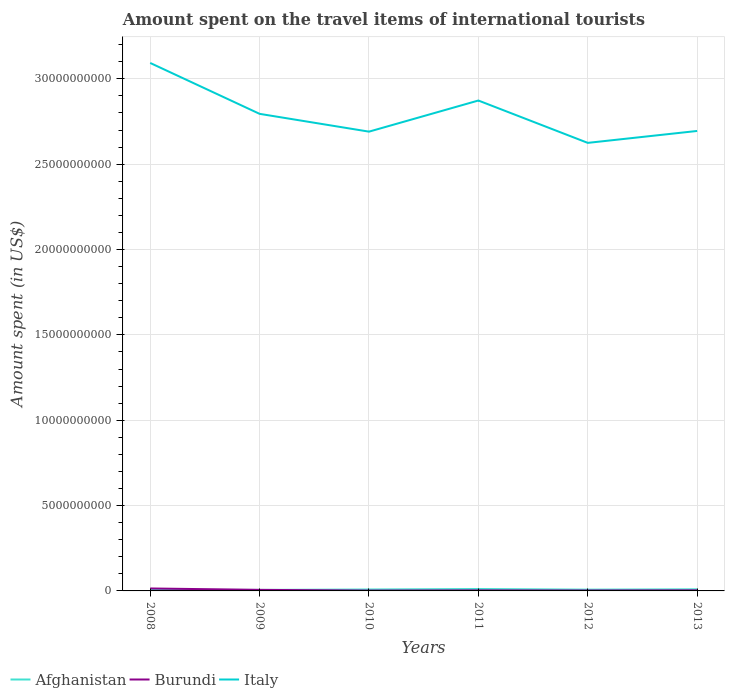How many different coloured lines are there?
Make the answer very short. 3. Is the number of lines equal to the number of legend labels?
Provide a succinct answer. Yes. Across all years, what is the maximum amount spent on the travel items of international tourists in Burundi?
Offer a very short reply. 2.00e+07. What is the total amount spent on the travel items of international tourists in Burundi in the graph?
Offer a terse response. 6.00e+06. What is the difference between the highest and the second highest amount spent on the travel items of international tourists in Afghanistan?
Provide a short and direct response. 5.80e+07. What is the difference between the highest and the lowest amount spent on the travel items of international tourists in Italy?
Keep it short and to the point. 2. Is the amount spent on the travel items of international tourists in Burundi strictly greater than the amount spent on the travel items of international tourists in Afghanistan over the years?
Your answer should be compact. No. How many lines are there?
Make the answer very short. 3. How many years are there in the graph?
Provide a succinct answer. 6. What is the difference between two consecutive major ticks on the Y-axis?
Your answer should be very brief. 5.00e+09. Are the values on the major ticks of Y-axis written in scientific E-notation?
Make the answer very short. No. Does the graph contain any zero values?
Offer a very short reply. No. Does the graph contain grids?
Give a very brief answer. Yes. Where does the legend appear in the graph?
Keep it short and to the point. Bottom left. How many legend labels are there?
Your answer should be compact. 3. What is the title of the graph?
Your answer should be compact. Amount spent on the travel items of international tourists. What is the label or title of the Y-axis?
Give a very brief answer. Amount spent (in US$). What is the Amount spent (in US$) in Afghanistan in 2008?
Give a very brief answer. 5.50e+07. What is the Amount spent (in US$) of Burundi in 2008?
Give a very brief answer. 1.44e+08. What is the Amount spent (in US$) of Italy in 2008?
Keep it short and to the point. 3.09e+1. What is the Amount spent (in US$) of Afghanistan in 2009?
Your answer should be compact. 5.90e+07. What is the Amount spent (in US$) in Burundi in 2009?
Provide a succinct answer. 6.20e+07. What is the Amount spent (in US$) in Italy in 2009?
Give a very brief answer. 2.80e+1. What is the Amount spent (in US$) in Afghanistan in 2010?
Your response must be concise. 8.30e+07. What is the Amount spent (in US$) of Italy in 2010?
Ensure brevity in your answer.  2.69e+1. What is the Amount spent (in US$) in Afghanistan in 2011?
Provide a succinct answer. 1.13e+08. What is the Amount spent (in US$) in Burundi in 2011?
Ensure brevity in your answer.  3.10e+07. What is the Amount spent (in US$) of Italy in 2011?
Your answer should be very brief. 2.87e+1. What is the Amount spent (in US$) in Afghanistan in 2012?
Give a very brief answer. 7.50e+07. What is the Amount spent (in US$) in Burundi in 2012?
Give a very brief answer. 2.50e+07. What is the Amount spent (in US$) in Italy in 2012?
Give a very brief answer. 2.62e+1. What is the Amount spent (in US$) in Afghanistan in 2013?
Make the answer very short. 9.40e+07. What is the Amount spent (in US$) of Burundi in 2013?
Your answer should be compact. 3.40e+07. What is the Amount spent (in US$) of Italy in 2013?
Your response must be concise. 2.69e+1. Across all years, what is the maximum Amount spent (in US$) of Afghanistan?
Make the answer very short. 1.13e+08. Across all years, what is the maximum Amount spent (in US$) of Burundi?
Make the answer very short. 1.44e+08. Across all years, what is the maximum Amount spent (in US$) of Italy?
Give a very brief answer. 3.09e+1. Across all years, what is the minimum Amount spent (in US$) of Afghanistan?
Your answer should be very brief. 5.50e+07. Across all years, what is the minimum Amount spent (in US$) of Italy?
Provide a short and direct response. 2.62e+1. What is the total Amount spent (in US$) in Afghanistan in the graph?
Your answer should be compact. 4.79e+08. What is the total Amount spent (in US$) in Burundi in the graph?
Provide a succinct answer. 3.16e+08. What is the total Amount spent (in US$) of Italy in the graph?
Provide a short and direct response. 1.68e+11. What is the difference between the Amount spent (in US$) of Burundi in 2008 and that in 2009?
Provide a succinct answer. 8.20e+07. What is the difference between the Amount spent (in US$) of Italy in 2008 and that in 2009?
Provide a short and direct response. 2.98e+09. What is the difference between the Amount spent (in US$) in Afghanistan in 2008 and that in 2010?
Give a very brief answer. -2.80e+07. What is the difference between the Amount spent (in US$) of Burundi in 2008 and that in 2010?
Your answer should be compact. 1.24e+08. What is the difference between the Amount spent (in US$) in Italy in 2008 and that in 2010?
Make the answer very short. 4.02e+09. What is the difference between the Amount spent (in US$) of Afghanistan in 2008 and that in 2011?
Make the answer very short. -5.80e+07. What is the difference between the Amount spent (in US$) of Burundi in 2008 and that in 2011?
Your response must be concise. 1.13e+08. What is the difference between the Amount spent (in US$) of Italy in 2008 and that in 2011?
Provide a succinct answer. 2.20e+09. What is the difference between the Amount spent (in US$) of Afghanistan in 2008 and that in 2012?
Provide a succinct answer. -2.00e+07. What is the difference between the Amount spent (in US$) of Burundi in 2008 and that in 2012?
Make the answer very short. 1.19e+08. What is the difference between the Amount spent (in US$) of Italy in 2008 and that in 2012?
Your answer should be compact. 4.68e+09. What is the difference between the Amount spent (in US$) in Afghanistan in 2008 and that in 2013?
Keep it short and to the point. -3.90e+07. What is the difference between the Amount spent (in US$) in Burundi in 2008 and that in 2013?
Provide a short and direct response. 1.10e+08. What is the difference between the Amount spent (in US$) in Italy in 2008 and that in 2013?
Offer a very short reply. 3.98e+09. What is the difference between the Amount spent (in US$) of Afghanistan in 2009 and that in 2010?
Offer a terse response. -2.40e+07. What is the difference between the Amount spent (in US$) of Burundi in 2009 and that in 2010?
Ensure brevity in your answer.  4.20e+07. What is the difference between the Amount spent (in US$) of Italy in 2009 and that in 2010?
Give a very brief answer. 1.04e+09. What is the difference between the Amount spent (in US$) in Afghanistan in 2009 and that in 2011?
Your answer should be compact. -5.40e+07. What is the difference between the Amount spent (in US$) of Burundi in 2009 and that in 2011?
Give a very brief answer. 3.10e+07. What is the difference between the Amount spent (in US$) in Italy in 2009 and that in 2011?
Your response must be concise. -7.80e+08. What is the difference between the Amount spent (in US$) of Afghanistan in 2009 and that in 2012?
Give a very brief answer. -1.60e+07. What is the difference between the Amount spent (in US$) in Burundi in 2009 and that in 2012?
Ensure brevity in your answer.  3.70e+07. What is the difference between the Amount spent (in US$) in Italy in 2009 and that in 2012?
Ensure brevity in your answer.  1.70e+09. What is the difference between the Amount spent (in US$) of Afghanistan in 2009 and that in 2013?
Offer a very short reply. -3.50e+07. What is the difference between the Amount spent (in US$) in Burundi in 2009 and that in 2013?
Your answer should be compact. 2.80e+07. What is the difference between the Amount spent (in US$) of Italy in 2009 and that in 2013?
Provide a succinct answer. 1.00e+09. What is the difference between the Amount spent (in US$) in Afghanistan in 2010 and that in 2011?
Keep it short and to the point. -3.00e+07. What is the difference between the Amount spent (in US$) of Burundi in 2010 and that in 2011?
Your response must be concise. -1.10e+07. What is the difference between the Amount spent (in US$) of Italy in 2010 and that in 2011?
Your answer should be very brief. -1.82e+09. What is the difference between the Amount spent (in US$) in Afghanistan in 2010 and that in 2012?
Provide a succinct answer. 8.00e+06. What is the difference between the Amount spent (in US$) of Burundi in 2010 and that in 2012?
Provide a short and direct response. -5.00e+06. What is the difference between the Amount spent (in US$) of Italy in 2010 and that in 2012?
Give a very brief answer. 6.58e+08. What is the difference between the Amount spent (in US$) in Afghanistan in 2010 and that in 2013?
Give a very brief answer. -1.10e+07. What is the difference between the Amount spent (in US$) in Burundi in 2010 and that in 2013?
Make the answer very short. -1.40e+07. What is the difference between the Amount spent (in US$) in Italy in 2010 and that in 2013?
Your answer should be very brief. -4.00e+07. What is the difference between the Amount spent (in US$) in Afghanistan in 2011 and that in 2012?
Ensure brevity in your answer.  3.80e+07. What is the difference between the Amount spent (in US$) in Burundi in 2011 and that in 2012?
Give a very brief answer. 6.00e+06. What is the difference between the Amount spent (in US$) in Italy in 2011 and that in 2012?
Offer a terse response. 2.48e+09. What is the difference between the Amount spent (in US$) in Afghanistan in 2011 and that in 2013?
Offer a terse response. 1.90e+07. What is the difference between the Amount spent (in US$) of Italy in 2011 and that in 2013?
Your answer should be compact. 1.78e+09. What is the difference between the Amount spent (in US$) in Afghanistan in 2012 and that in 2013?
Offer a terse response. -1.90e+07. What is the difference between the Amount spent (in US$) in Burundi in 2012 and that in 2013?
Your response must be concise. -9.00e+06. What is the difference between the Amount spent (in US$) of Italy in 2012 and that in 2013?
Keep it short and to the point. -6.98e+08. What is the difference between the Amount spent (in US$) in Afghanistan in 2008 and the Amount spent (in US$) in Burundi in 2009?
Keep it short and to the point. -7.00e+06. What is the difference between the Amount spent (in US$) in Afghanistan in 2008 and the Amount spent (in US$) in Italy in 2009?
Provide a succinct answer. -2.79e+1. What is the difference between the Amount spent (in US$) of Burundi in 2008 and the Amount spent (in US$) of Italy in 2009?
Your answer should be very brief. -2.78e+1. What is the difference between the Amount spent (in US$) in Afghanistan in 2008 and the Amount spent (in US$) in Burundi in 2010?
Provide a short and direct response. 3.50e+07. What is the difference between the Amount spent (in US$) of Afghanistan in 2008 and the Amount spent (in US$) of Italy in 2010?
Keep it short and to the point. -2.69e+1. What is the difference between the Amount spent (in US$) of Burundi in 2008 and the Amount spent (in US$) of Italy in 2010?
Give a very brief answer. -2.68e+1. What is the difference between the Amount spent (in US$) in Afghanistan in 2008 and the Amount spent (in US$) in Burundi in 2011?
Your answer should be very brief. 2.40e+07. What is the difference between the Amount spent (in US$) in Afghanistan in 2008 and the Amount spent (in US$) in Italy in 2011?
Provide a short and direct response. -2.87e+1. What is the difference between the Amount spent (in US$) of Burundi in 2008 and the Amount spent (in US$) of Italy in 2011?
Keep it short and to the point. -2.86e+1. What is the difference between the Amount spent (in US$) of Afghanistan in 2008 and the Amount spent (in US$) of Burundi in 2012?
Ensure brevity in your answer.  3.00e+07. What is the difference between the Amount spent (in US$) in Afghanistan in 2008 and the Amount spent (in US$) in Italy in 2012?
Offer a terse response. -2.62e+1. What is the difference between the Amount spent (in US$) in Burundi in 2008 and the Amount spent (in US$) in Italy in 2012?
Offer a terse response. -2.61e+1. What is the difference between the Amount spent (in US$) of Afghanistan in 2008 and the Amount spent (in US$) of Burundi in 2013?
Offer a very short reply. 2.10e+07. What is the difference between the Amount spent (in US$) of Afghanistan in 2008 and the Amount spent (in US$) of Italy in 2013?
Give a very brief answer. -2.69e+1. What is the difference between the Amount spent (in US$) of Burundi in 2008 and the Amount spent (in US$) of Italy in 2013?
Your answer should be compact. -2.68e+1. What is the difference between the Amount spent (in US$) of Afghanistan in 2009 and the Amount spent (in US$) of Burundi in 2010?
Provide a short and direct response. 3.90e+07. What is the difference between the Amount spent (in US$) of Afghanistan in 2009 and the Amount spent (in US$) of Italy in 2010?
Provide a succinct answer. -2.68e+1. What is the difference between the Amount spent (in US$) in Burundi in 2009 and the Amount spent (in US$) in Italy in 2010?
Your response must be concise. -2.68e+1. What is the difference between the Amount spent (in US$) in Afghanistan in 2009 and the Amount spent (in US$) in Burundi in 2011?
Give a very brief answer. 2.80e+07. What is the difference between the Amount spent (in US$) of Afghanistan in 2009 and the Amount spent (in US$) of Italy in 2011?
Give a very brief answer. -2.87e+1. What is the difference between the Amount spent (in US$) of Burundi in 2009 and the Amount spent (in US$) of Italy in 2011?
Offer a terse response. -2.87e+1. What is the difference between the Amount spent (in US$) of Afghanistan in 2009 and the Amount spent (in US$) of Burundi in 2012?
Keep it short and to the point. 3.40e+07. What is the difference between the Amount spent (in US$) of Afghanistan in 2009 and the Amount spent (in US$) of Italy in 2012?
Give a very brief answer. -2.62e+1. What is the difference between the Amount spent (in US$) of Burundi in 2009 and the Amount spent (in US$) of Italy in 2012?
Give a very brief answer. -2.62e+1. What is the difference between the Amount spent (in US$) in Afghanistan in 2009 and the Amount spent (in US$) in Burundi in 2013?
Keep it short and to the point. 2.50e+07. What is the difference between the Amount spent (in US$) in Afghanistan in 2009 and the Amount spent (in US$) in Italy in 2013?
Keep it short and to the point. -2.69e+1. What is the difference between the Amount spent (in US$) in Burundi in 2009 and the Amount spent (in US$) in Italy in 2013?
Keep it short and to the point. -2.69e+1. What is the difference between the Amount spent (in US$) of Afghanistan in 2010 and the Amount spent (in US$) of Burundi in 2011?
Your answer should be compact. 5.20e+07. What is the difference between the Amount spent (in US$) in Afghanistan in 2010 and the Amount spent (in US$) in Italy in 2011?
Keep it short and to the point. -2.86e+1. What is the difference between the Amount spent (in US$) in Burundi in 2010 and the Amount spent (in US$) in Italy in 2011?
Offer a very short reply. -2.87e+1. What is the difference between the Amount spent (in US$) in Afghanistan in 2010 and the Amount spent (in US$) in Burundi in 2012?
Offer a terse response. 5.80e+07. What is the difference between the Amount spent (in US$) in Afghanistan in 2010 and the Amount spent (in US$) in Italy in 2012?
Your answer should be very brief. -2.62e+1. What is the difference between the Amount spent (in US$) in Burundi in 2010 and the Amount spent (in US$) in Italy in 2012?
Ensure brevity in your answer.  -2.62e+1. What is the difference between the Amount spent (in US$) of Afghanistan in 2010 and the Amount spent (in US$) of Burundi in 2013?
Keep it short and to the point. 4.90e+07. What is the difference between the Amount spent (in US$) in Afghanistan in 2010 and the Amount spent (in US$) in Italy in 2013?
Make the answer very short. -2.69e+1. What is the difference between the Amount spent (in US$) of Burundi in 2010 and the Amount spent (in US$) of Italy in 2013?
Ensure brevity in your answer.  -2.69e+1. What is the difference between the Amount spent (in US$) in Afghanistan in 2011 and the Amount spent (in US$) in Burundi in 2012?
Your response must be concise. 8.80e+07. What is the difference between the Amount spent (in US$) in Afghanistan in 2011 and the Amount spent (in US$) in Italy in 2012?
Your answer should be compact. -2.61e+1. What is the difference between the Amount spent (in US$) in Burundi in 2011 and the Amount spent (in US$) in Italy in 2012?
Provide a succinct answer. -2.62e+1. What is the difference between the Amount spent (in US$) of Afghanistan in 2011 and the Amount spent (in US$) of Burundi in 2013?
Your answer should be very brief. 7.90e+07. What is the difference between the Amount spent (in US$) in Afghanistan in 2011 and the Amount spent (in US$) in Italy in 2013?
Ensure brevity in your answer.  -2.68e+1. What is the difference between the Amount spent (in US$) of Burundi in 2011 and the Amount spent (in US$) of Italy in 2013?
Make the answer very short. -2.69e+1. What is the difference between the Amount spent (in US$) in Afghanistan in 2012 and the Amount spent (in US$) in Burundi in 2013?
Provide a short and direct response. 4.10e+07. What is the difference between the Amount spent (in US$) in Afghanistan in 2012 and the Amount spent (in US$) in Italy in 2013?
Your answer should be very brief. -2.69e+1. What is the difference between the Amount spent (in US$) of Burundi in 2012 and the Amount spent (in US$) of Italy in 2013?
Give a very brief answer. -2.69e+1. What is the average Amount spent (in US$) of Afghanistan per year?
Keep it short and to the point. 7.98e+07. What is the average Amount spent (in US$) of Burundi per year?
Ensure brevity in your answer.  5.27e+07. What is the average Amount spent (in US$) of Italy per year?
Ensure brevity in your answer.  2.80e+1. In the year 2008, what is the difference between the Amount spent (in US$) in Afghanistan and Amount spent (in US$) in Burundi?
Ensure brevity in your answer.  -8.90e+07. In the year 2008, what is the difference between the Amount spent (in US$) in Afghanistan and Amount spent (in US$) in Italy?
Offer a terse response. -3.09e+1. In the year 2008, what is the difference between the Amount spent (in US$) of Burundi and Amount spent (in US$) of Italy?
Provide a succinct answer. -3.08e+1. In the year 2009, what is the difference between the Amount spent (in US$) of Afghanistan and Amount spent (in US$) of Burundi?
Give a very brief answer. -3.00e+06. In the year 2009, what is the difference between the Amount spent (in US$) of Afghanistan and Amount spent (in US$) of Italy?
Keep it short and to the point. -2.79e+1. In the year 2009, what is the difference between the Amount spent (in US$) of Burundi and Amount spent (in US$) of Italy?
Give a very brief answer. -2.79e+1. In the year 2010, what is the difference between the Amount spent (in US$) of Afghanistan and Amount spent (in US$) of Burundi?
Ensure brevity in your answer.  6.30e+07. In the year 2010, what is the difference between the Amount spent (in US$) of Afghanistan and Amount spent (in US$) of Italy?
Keep it short and to the point. -2.68e+1. In the year 2010, what is the difference between the Amount spent (in US$) in Burundi and Amount spent (in US$) in Italy?
Offer a terse response. -2.69e+1. In the year 2011, what is the difference between the Amount spent (in US$) of Afghanistan and Amount spent (in US$) of Burundi?
Provide a short and direct response. 8.20e+07. In the year 2011, what is the difference between the Amount spent (in US$) of Afghanistan and Amount spent (in US$) of Italy?
Provide a short and direct response. -2.86e+1. In the year 2011, what is the difference between the Amount spent (in US$) in Burundi and Amount spent (in US$) in Italy?
Your answer should be very brief. -2.87e+1. In the year 2012, what is the difference between the Amount spent (in US$) of Afghanistan and Amount spent (in US$) of Burundi?
Your answer should be very brief. 5.00e+07. In the year 2012, what is the difference between the Amount spent (in US$) of Afghanistan and Amount spent (in US$) of Italy?
Your answer should be compact. -2.62e+1. In the year 2012, what is the difference between the Amount spent (in US$) of Burundi and Amount spent (in US$) of Italy?
Your response must be concise. -2.62e+1. In the year 2013, what is the difference between the Amount spent (in US$) in Afghanistan and Amount spent (in US$) in Burundi?
Your answer should be very brief. 6.00e+07. In the year 2013, what is the difference between the Amount spent (in US$) of Afghanistan and Amount spent (in US$) of Italy?
Keep it short and to the point. -2.69e+1. In the year 2013, what is the difference between the Amount spent (in US$) in Burundi and Amount spent (in US$) in Italy?
Keep it short and to the point. -2.69e+1. What is the ratio of the Amount spent (in US$) in Afghanistan in 2008 to that in 2009?
Your answer should be compact. 0.93. What is the ratio of the Amount spent (in US$) of Burundi in 2008 to that in 2009?
Keep it short and to the point. 2.32. What is the ratio of the Amount spent (in US$) of Italy in 2008 to that in 2009?
Your answer should be compact. 1.11. What is the ratio of the Amount spent (in US$) in Afghanistan in 2008 to that in 2010?
Keep it short and to the point. 0.66. What is the ratio of the Amount spent (in US$) in Italy in 2008 to that in 2010?
Offer a terse response. 1.15. What is the ratio of the Amount spent (in US$) in Afghanistan in 2008 to that in 2011?
Keep it short and to the point. 0.49. What is the ratio of the Amount spent (in US$) in Burundi in 2008 to that in 2011?
Your answer should be compact. 4.65. What is the ratio of the Amount spent (in US$) in Italy in 2008 to that in 2011?
Offer a very short reply. 1.08. What is the ratio of the Amount spent (in US$) of Afghanistan in 2008 to that in 2012?
Your response must be concise. 0.73. What is the ratio of the Amount spent (in US$) of Burundi in 2008 to that in 2012?
Ensure brevity in your answer.  5.76. What is the ratio of the Amount spent (in US$) of Italy in 2008 to that in 2012?
Provide a short and direct response. 1.18. What is the ratio of the Amount spent (in US$) of Afghanistan in 2008 to that in 2013?
Give a very brief answer. 0.59. What is the ratio of the Amount spent (in US$) of Burundi in 2008 to that in 2013?
Keep it short and to the point. 4.24. What is the ratio of the Amount spent (in US$) in Italy in 2008 to that in 2013?
Make the answer very short. 1.15. What is the ratio of the Amount spent (in US$) in Afghanistan in 2009 to that in 2010?
Your answer should be very brief. 0.71. What is the ratio of the Amount spent (in US$) of Italy in 2009 to that in 2010?
Your answer should be compact. 1.04. What is the ratio of the Amount spent (in US$) in Afghanistan in 2009 to that in 2011?
Offer a very short reply. 0.52. What is the ratio of the Amount spent (in US$) of Burundi in 2009 to that in 2011?
Keep it short and to the point. 2. What is the ratio of the Amount spent (in US$) of Italy in 2009 to that in 2011?
Provide a short and direct response. 0.97. What is the ratio of the Amount spent (in US$) in Afghanistan in 2009 to that in 2012?
Your response must be concise. 0.79. What is the ratio of the Amount spent (in US$) of Burundi in 2009 to that in 2012?
Your answer should be compact. 2.48. What is the ratio of the Amount spent (in US$) of Italy in 2009 to that in 2012?
Ensure brevity in your answer.  1.06. What is the ratio of the Amount spent (in US$) of Afghanistan in 2009 to that in 2013?
Your answer should be very brief. 0.63. What is the ratio of the Amount spent (in US$) in Burundi in 2009 to that in 2013?
Your answer should be compact. 1.82. What is the ratio of the Amount spent (in US$) in Italy in 2009 to that in 2013?
Provide a short and direct response. 1.04. What is the ratio of the Amount spent (in US$) of Afghanistan in 2010 to that in 2011?
Provide a short and direct response. 0.73. What is the ratio of the Amount spent (in US$) in Burundi in 2010 to that in 2011?
Offer a terse response. 0.65. What is the ratio of the Amount spent (in US$) of Italy in 2010 to that in 2011?
Your answer should be very brief. 0.94. What is the ratio of the Amount spent (in US$) of Afghanistan in 2010 to that in 2012?
Ensure brevity in your answer.  1.11. What is the ratio of the Amount spent (in US$) in Italy in 2010 to that in 2012?
Give a very brief answer. 1.03. What is the ratio of the Amount spent (in US$) in Afghanistan in 2010 to that in 2013?
Ensure brevity in your answer.  0.88. What is the ratio of the Amount spent (in US$) in Burundi in 2010 to that in 2013?
Keep it short and to the point. 0.59. What is the ratio of the Amount spent (in US$) of Italy in 2010 to that in 2013?
Your answer should be very brief. 1. What is the ratio of the Amount spent (in US$) of Afghanistan in 2011 to that in 2012?
Your answer should be compact. 1.51. What is the ratio of the Amount spent (in US$) of Burundi in 2011 to that in 2012?
Keep it short and to the point. 1.24. What is the ratio of the Amount spent (in US$) of Italy in 2011 to that in 2012?
Give a very brief answer. 1.09. What is the ratio of the Amount spent (in US$) in Afghanistan in 2011 to that in 2013?
Your answer should be compact. 1.2. What is the ratio of the Amount spent (in US$) in Burundi in 2011 to that in 2013?
Provide a succinct answer. 0.91. What is the ratio of the Amount spent (in US$) in Italy in 2011 to that in 2013?
Provide a short and direct response. 1.07. What is the ratio of the Amount spent (in US$) in Afghanistan in 2012 to that in 2013?
Give a very brief answer. 0.8. What is the ratio of the Amount spent (in US$) of Burundi in 2012 to that in 2013?
Give a very brief answer. 0.74. What is the ratio of the Amount spent (in US$) of Italy in 2012 to that in 2013?
Give a very brief answer. 0.97. What is the difference between the highest and the second highest Amount spent (in US$) of Afghanistan?
Provide a succinct answer. 1.90e+07. What is the difference between the highest and the second highest Amount spent (in US$) of Burundi?
Provide a short and direct response. 8.20e+07. What is the difference between the highest and the second highest Amount spent (in US$) in Italy?
Keep it short and to the point. 2.20e+09. What is the difference between the highest and the lowest Amount spent (in US$) of Afghanistan?
Keep it short and to the point. 5.80e+07. What is the difference between the highest and the lowest Amount spent (in US$) of Burundi?
Keep it short and to the point. 1.24e+08. What is the difference between the highest and the lowest Amount spent (in US$) of Italy?
Your response must be concise. 4.68e+09. 